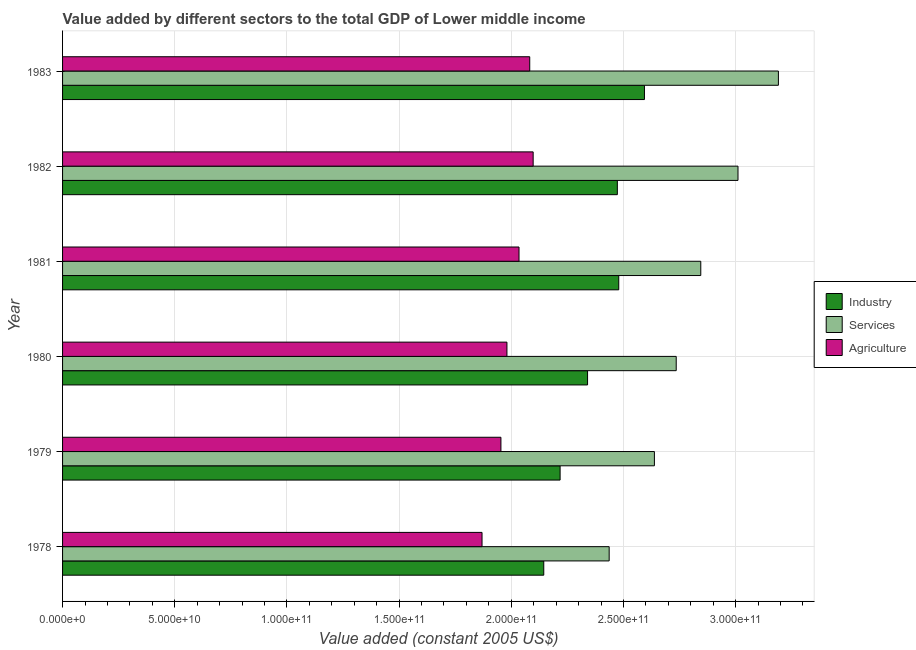How many bars are there on the 3rd tick from the top?
Ensure brevity in your answer.  3. How many bars are there on the 1st tick from the bottom?
Your response must be concise. 3. What is the label of the 4th group of bars from the top?
Ensure brevity in your answer.  1980. What is the value added by agricultural sector in 1979?
Your answer should be compact. 1.95e+11. Across all years, what is the maximum value added by industrial sector?
Provide a short and direct response. 2.59e+11. Across all years, what is the minimum value added by industrial sector?
Your answer should be very brief. 2.14e+11. In which year was the value added by industrial sector minimum?
Keep it short and to the point. 1978. What is the total value added by agricultural sector in the graph?
Provide a succinct answer. 1.20e+12. What is the difference between the value added by industrial sector in 1981 and that in 1982?
Provide a succinct answer. 6.25e+08. What is the difference between the value added by services in 1978 and the value added by industrial sector in 1982?
Ensure brevity in your answer.  -3.64e+09. What is the average value added by industrial sector per year?
Offer a very short reply. 2.37e+11. In the year 1978, what is the difference between the value added by industrial sector and value added by services?
Make the answer very short. -2.92e+1. In how many years, is the value added by services greater than 20000000000 US$?
Offer a terse response. 6. What is the ratio of the value added by industrial sector in 1978 to that in 1980?
Ensure brevity in your answer.  0.92. Is the value added by industrial sector in 1978 less than that in 1982?
Offer a terse response. Yes. Is the difference between the value added by industrial sector in 1980 and 1981 greater than the difference between the value added by agricultural sector in 1980 and 1981?
Your answer should be compact. No. What is the difference between the highest and the second highest value added by agricultural sector?
Keep it short and to the point. 1.53e+09. What is the difference between the highest and the lowest value added by industrial sector?
Provide a succinct answer. 4.49e+1. In how many years, is the value added by services greater than the average value added by services taken over all years?
Your answer should be very brief. 3. What does the 3rd bar from the top in 1980 represents?
Your answer should be compact. Industry. What does the 1st bar from the bottom in 1978 represents?
Offer a terse response. Industry. How many years are there in the graph?
Offer a terse response. 6. What is the difference between two consecutive major ticks on the X-axis?
Give a very brief answer. 5.00e+1. Are the values on the major ticks of X-axis written in scientific E-notation?
Your response must be concise. Yes. Does the graph contain any zero values?
Give a very brief answer. No. Does the graph contain grids?
Ensure brevity in your answer.  Yes. Where does the legend appear in the graph?
Offer a terse response. Center right. How are the legend labels stacked?
Make the answer very short. Vertical. What is the title of the graph?
Your answer should be very brief. Value added by different sectors to the total GDP of Lower middle income. What is the label or title of the X-axis?
Provide a succinct answer. Value added (constant 2005 US$). What is the label or title of the Y-axis?
Offer a terse response. Year. What is the Value added (constant 2005 US$) in Industry in 1978?
Give a very brief answer. 2.14e+11. What is the Value added (constant 2005 US$) in Services in 1978?
Give a very brief answer. 2.44e+11. What is the Value added (constant 2005 US$) of Agriculture in 1978?
Provide a short and direct response. 1.87e+11. What is the Value added (constant 2005 US$) of Industry in 1979?
Provide a short and direct response. 2.22e+11. What is the Value added (constant 2005 US$) of Services in 1979?
Keep it short and to the point. 2.64e+11. What is the Value added (constant 2005 US$) of Agriculture in 1979?
Your answer should be very brief. 1.95e+11. What is the Value added (constant 2005 US$) in Industry in 1980?
Give a very brief answer. 2.34e+11. What is the Value added (constant 2005 US$) in Services in 1980?
Ensure brevity in your answer.  2.74e+11. What is the Value added (constant 2005 US$) of Agriculture in 1980?
Your answer should be compact. 1.98e+11. What is the Value added (constant 2005 US$) in Industry in 1981?
Give a very brief answer. 2.48e+11. What is the Value added (constant 2005 US$) of Services in 1981?
Make the answer very short. 2.84e+11. What is the Value added (constant 2005 US$) of Agriculture in 1981?
Your answer should be compact. 2.03e+11. What is the Value added (constant 2005 US$) in Industry in 1982?
Provide a succinct answer. 2.47e+11. What is the Value added (constant 2005 US$) of Services in 1982?
Your response must be concise. 3.01e+11. What is the Value added (constant 2005 US$) in Agriculture in 1982?
Make the answer very short. 2.10e+11. What is the Value added (constant 2005 US$) in Industry in 1983?
Offer a terse response. 2.59e+11. What is the Value added (constant 2005 US$) in Services in 1983?
Your answer should be very brief. 3.19e+11. What is the Value added (constant 2005 US$) of Agriculture in 1983?
Your answer should be very brief. 2.08e+11. Across all years, what is the maximum Value added (constant 2005 US$) in Industry?
Offer a very short reply. 2.59e+11. Across all years, what is the maximum Value added (constant 2005 US$) in Services?
Provide a succinct answer. 3.19e+11. Across all years, what is the maximum Value added (constant 2005 US$) in Agriculture?
Give a very brief answer. 2.10e+11. Across all years, what is the minimum Value added (constant 2005 US$) in Industry?
Your response must be concise. 2.14e+11. Across all years, what is the minimum Value added (constant 2005 US$) of Services?
Keep it short and to the point. 2.44e+11. Across all years, what is the minimum Value added (constant 2005 US$) of Agriculture?
Offer a very short reply. 1.87e+11. What is the total Value added (constant 2005 US$) in Industry in the graph?
Give a very brief answer. 1.42e+12. What is the total Value added (constant 2005 US$) in Services in the graph?
Provide a short and direct response. 1.69e+12. What is the total Value added (constant 2005 US$) in Agriculture in the graph?
Ensure brevity in your answer.  1.20e+12. What is the difference between the Value added (constant 2005 US$) of Industry in 1978 and that in 1979?
Offer a very short reply. -7.28e+09. What is the difference between the Value added (constant 2005 US$) of Services in 1978 and that in 1979?
Provide a short and direct response. -2.02e+1. What is the difference between the Value added (constant 2005 US$) of Agriculture in 1978 and that in 1979?
Make the answer very short. -8.42e+09. What is the difference between the Value added (constant 2005 US$) of Industry in 1978 and that in 1980?
Ensure brevity in your answer.  -1.95e+1. What is the difference between the Value added (constant 2005 US$) in Services in 1978 and that in 1980?
Provide a short and direct response. -2.99e+1. What is the difference between the Value added (constant 2005 US$) of Agriculture in 1978 and that in 1980?
Offer a terse response. -1.11e+1. What is the difference between the Value added (constant 2005 US$) in Industry in 1978 and that in 1981?
Your answer should be compact. -3.34e+1. What is the difference between the Value added (constant 2005 US$) of Services in 1978 and that in 1981?
Your answer should be compact. -4.08e+1. What is the difference between the Value added (constant 2005 US$) in Agriculture in 1978 and that in 1981?
Make the answer very short. -1.65e+1. What is the difference between the Value added (constant 2005 US$) in Industry in 1978 and that in 1982?
Your answer should be compact. -3.28e+1. What is the difference between the Value added (constant 2005 US$) of Services in 1978 and that in 1982?
Ensure brevity in your answer.  -5.74e+1. What is the difference between the Value added (constant 2005 US$) of Agriculture in 1978 and that in 1982?
Your answer should be compact. -2.28e+1. What is the difference between the Value added (constant 2005 US$) of Industry in 1978 and that in 1983?
Your response must be concise. -4.49e+1. What is the difference between the Value added (constant 2005 US$) of Services in 1978 and that in 1983?
Provide a succinct answer. -7.54e+1. What is the difference between the Value added (constant 2005 US$) of Agriculture in 1978 and that in 1983?
Make the answer very short. -2.13e+1. What is the difference between the Value added (constant 2005 US$) in Industry in 1979 and that in 1980?
Offer a terse response. -1.22e+1. What is the difference between the Value added (constant 2005 US$) in Services in 1979 and that in 1980?
Give a very brief answer. -9.73e+09. What is the difference between the Value added (constant 2005 US$) of Agriculture in 1979 and that in 1980?
Make the answer very short. -2.68e+09. What is the difference between the Value added (constant 2005 US$) in Industry in 1979 and that in 1981?
Your answer should be very brief. -2.61e+1. What is the difference between the Value added (constant 2005 US$) in Services in 1979 and that in 1981?
Keep it short and to the point. -2.07e+1. What is the difference between the Value added (constant 2005 US$) of Agriculture in 1979 and that in 1981?
Offer a very short reply. -8.06e+09. What is the difference between the Value added (constant 2005 US$) of Industry in 1979 and that in 1982?
Offer a terse response. -2.55e+1. What is the difference between the Value added (constant 2005 US$) in Services in 1979 and that in 1982?
Offer a terse response. -3.73e+1. What is the difference between the Value added (constant 2005 US$) in Agriculture in 1979 and that in 1982?
Provide a short and direct response. -1.44e+1. What is the difference between the Value added (constant 2005 US$) of Industry in 1979 and that in 1983?
Give a very brief answer. -3.76e+1. What is the difference between the Value added (constant 2005 US$) in Services in 1979 and that in 1983?
Give a very brief answer. -5.53e+1. What is the difference between the Value added (constant 2005 US$) in Agriculture in 1979 and that in 1983?
Keep it short and to the point. -1.28e+1. What is the difference between the Value added (constant 2005 US$) of Industry in 1980 and that in 1981?
Make the answer very short. -1.39e+1. What is the difference between the Value added (constant 2005 US$) of Services in 1980 and that in 1981?
Your answer should be very brief. -1.09e+1. What is the difference between the Value added (constant 2005 US$) of Agriculture in 1980 and that in 1981?
Provide a succinct answer. -5.38e+09. What is the difference between the Value added (constant 2005 US$) of Industry in 1980 and that in 1982?
Make the answer very short. -1.33e+1. What is the difference between the Value added (constant 2005 US$) of Services in 1980 and that in 1982?
Keep it short and to the point. -2.75e+1. What is the difference between the Value added (constant 2005 US$) of Agriculture in 1980 and that in 1982?
Make the answer very short. -1.17e+1. What is the difference between the Value added (constant 2005 US$) in Industry in 1980 and that in 1983?
Your answer should be compact. -2.54e+1. What is the difference between the Value added (constant 2005 US$) in Services in 1980 and that in 1983?
Your answer should be very brief. -4.55e+1. What is the difference between the Value added (constant 2005 US$) in Agriculture in 1980 and that in 1983?
Your answer should be very brief. -1.02e+1. What is the difference between the Value added (constant 2005 US$) of Industry in 1981 and that in 1982?
Your answer should be compact. 6.25e+08. What is the difference between the Value added (constant 2005 US$) in Services in 1981 and that in 1982?
Ensure brevity in your answer.  -1.66e+1. What is the difference between the Value added (constant 2005 US$) in Agriculture in 1981 and that in 1982?
Keep it short and to the point. -6.31e+09. What is the difference between the Value added (constant 2005 US$) of Industry in 1981 and that in 1983?
Provide a short and direct response. -1.15e+1. What is the difference between the Value added (constant 2005 US$) in Services in 1981 and that in 1983?
Give a very brief answer. -3.46e+1. What is the difference between the Value added (constant 2005 US$) of Agriculture in 1981 and that in 1983?
Offer a very short reply. -4.77e+09. What is the difference between the Value added (constant 2005 US$) of Industry in 1982 and that in 1983?
Your answer should be very brief. -1.21e+1. What is the difference between the Value added (constant 2005 US$) in Services in 1982 and that in 1983?
Your answer should be compact. -1.80e+1. What is the difference between the Value added (constant 2005 US$) in Agriculture in 1982 and that in 1983?
Give a very brief answer. 1.53e+09. What is the difference between the Value added (constant 2005 US$) in Industry in 1978 and the Value added (constant 2005 US$) in Services in 1979?
Offer a terse response. -4.93e+1. What is the difference between the Value added (constant 2005 US$) in Industry in 1978 and the Value added (constant 2005 US$) in Agriculture in 1979?
Offer a terse response. 1.91e+1. What is the difference between the Value added (constant 2005 US$) of Services in 1978 and the Value added (constant 2005 US$) of Agriculture in 1979?
Your answer should be very brief. 4.82e+1. What is the difference between the Value added (constant 2005 US$) of Industry in 1978 and the Value added (constant 2005 US$) of Services in 1980?
Make the answer very short. -5.90e+1. What is the difference between the Value added (constant 2005 US$) of Industry in 1978 and the Value added (constant 2005 US$) of Agriculture in 1980?
Make the answer very short. 1.64e+1. What is the difference between the Value added (constant 2005 US$) in Services in 1978 and the Value added (constant 2005 US$) in Agriculture in 1980?
Your answer should be very brief. 4.56e+1. What is the difference between the Value added (constant 2005 US$) of Industry in 1978 and the Value added (constant 2005 US$) of Services in 1981?
Give a very brief answer. -7.00e+1. What is the difference between the Value added (constant 2005 US$) in Industry in 1978 and the Value added (constant 2005 US$) in Agriculture in 1981?
Offer a terse response. 1.10e+1. What is the difference between the Value added (constant 2005 US$) in Services in 1978 and the Value added (constant 2005 US$) in Agriculture in 1981?
Make the answer very short. 4.02e+1. What is the difference between the Value added (constant 2005 US$) of Industry in 1978 and the Value added (constant 2005 US$) of Services in 1982?
Your answer should be very brief. -8.66e+1. What is the difference between the Value added (constant 2005 US$) in Industry in 1978 and the Value added (constant 2005 US$) in Agriculture in 1982?
Make the answer very short. 4.73e+09. What is the difference between the Value added (constant 2005 US$) of Services in 1978 and the Value added (constant 2005 US$) of Agriculture in 1982?
Provide a succinct answer. 3.39e+1. What is the difference between the Value added (constant 2005 US$) of Industry in 1978 and the Value added (constant 2005 US$) of Services in 1983?
Give a very brief answer. -1.05e+11. What is the difference between the Value added (constant 2005 US$) in Industry in 1978 and the Value added (constant 2005 US$) in Agriculture in 1983?
Ensure brevity in your answer.  6.26e+09. What is the difference between the Value added (constant 2005 US$) of Services in 1978 and the Value added (constant 2005 US$) of Agriculture in 1983?
Your response must be concise. 3.54e+1. What is the difference between the Value added (constant 2005 US$) of Industry in 1979 and the Value added (constant 2005 US$) of Services in 1980?
Offer a very short reply. -5.18e+1. What is the difference between the Value added (constant 2005 US$) in Industry in 1979 and the Value added (constant 2005 US$) in Agriculture in 1980?
Provide a short and direct response. 2.37e+1. What is the difference between the Value added (constant 2005 US$) of Services in 1979 and the Value added (constant 2005 US$) of Agriculture in 1980?
Your response must be concise. 6.57e+1. What is the difference between the Value added (constant 2005 US$) of Industry in 1979 and the Value added (constant 2005 US$) of Services in 1981?
Your answer should be compact. -6.27e+1. What is the difference between the Value added (constant 2005 US$) in Industry in 1979 and the Value added (constant 2005 US$) in Agriculture in 1981?
Your answer should be compact. 1.83e+1. What is the difference between the Value added (constant 2005 US$) in Services in 1979 and the Value added (constant 2005 US$) in Agriculture in 1981?
Provide a succinct answer. 6.03e+1. What is the difference between the Value added (constant 2005 US$) in Industry in 1979 and the Value added (constant 2005 US$) in Services in 1982?
Provide a short and direct response. -7.93e+1. What is the difference between the Value added (constant 2005 US$) of Industry in 1979 and the Value added (constant 2005 US$) of Agriculture in 1982?
Offer a terse response. 1.20e+1. What is the difference between the Value added (constant 2005 US$) of Services in 1979 and the Value added (constant 2005 US$) of Agriculture in 1982?
Make the answer very short. 5.40e+1. What is the difference between the Value added (constant 2005 US$) of Industry in 1979 and the Value added (constant 2005 US$) of Services in 1983?
Your answer should be very brief. -9.73e+1. What is the difference between the Value added (constant 2005 US$) in Industry in 1979 and the Value added (constant 2005 US$) in Agriculture in 1983?
Offer a terse response. 1.35e+1. What is the difference between the Value added (constant 2005 US$) in Services in 1979 and the Value added (constant 2005 US$) in Agriculture in 1983?
Provide a short and direct response. 5.56e+1. What is the difference between the Value added (constant 2005 US$) in Industry in 1980 and the Value added (constant 2005 US$) in Services in 1981?
Offer a very short reply. -5.05e+1. What is the difference between the Value added (constant 2005 US$) of Industry in 1980 and the Value added (constant 2005 US$) of Agriculture in 1981?
Your answer should be very brief. 3.06e+1. What is the difference between the Value added (constant 2005 US$) of Services in 1980 and the Value added (constant 2005 US$) of Agriculture in 1981?
Your answer should be very brief. 7.01e+1. What is the difference between the Value added (constant 2005 US$) of Industry in 1980 and the Value added (constant 2005 US$) of Services in 1982?
Provide a succinct answer. -6.71e+1. What is the difference between the Value added (constant 2005 US$) in Industry in 1980 and the Value added (constant 2005 US$) in Agriculture in 1982?
Provide a short and direct response. 2.42e+1. What is the difference between the Value added (constant 2005 US$) in Services in 1980 and the Value added (constant 2005 US$) in Agriculture in 1982?
Provide a succinct answer. 6.38e+1. What is the difference between the Value added (constant 2005 US$) of Industry in 1980 and the Value added (constant 2005 US$) of Services in 1983?
Provide a succinct answer. -8.51e+1. What is the difference between the Value added (constant 2005 US$) of Industry in 1980 and the Value added (constant 2005 US$) of Agriculture in 1983?
Ensure brevity in your answer.  2.58e+1. What is the difference between the Value added (constant 2005 US$) in Services in 1980 and the Value added (constant 2005 US$) in Agriculture in 1983?
Ensure brevity in your answer.  6.53e+1. What is the difference between the Value added (constant 2005 US$) in Industry in 1981 and the Value added (constant 2005 US$) in Services in 1982?
Your response must be concise. -5.32e+1. What is the difference between the Value added (constant 2005 US$) of Industry in 1981 and the Value added (constant 2005 US$) of Agriculture in 1982?
Keep it short and to the point. 3.81e+1. What is the difference between the Value added (constant 2005 US$) of Services in 1981 and the Value added (constant 2005 US$) of Agriculture in 1982?
Your answer should be compact. 7.47e+1. What is the difference between the Value added (constant 2005 US$) in Industry in 1981 and the Value added (constant 2005 US$) in Services in 1983?
Ensure brevity in your answer.  -7.12e+1. What is the difference between the Value added (constant 2005 US$) of Industry in 1981 and the Value added (constant 2005 US$) of Agriculture in 1983?
Offer a terse response. 3.97e+1. What is the difference between the Value added (constant 2005 US$) in Services in 1981 and the Value added (constant 2005 US$) in Agriculture in 1983?
Make the answer very short. 7.62e+1. What is the difference between the Value added (constant 2005 US$) in Industry in 1982 and the Value added (constant 2005 US$) in Services in 1983?
Offer a very short reply. -7.18e+1. What is the difference between the Value added (constant 2005 US$) in Industry in 1982 and the Value added (constant 2005 US$) in Agriculture in 1983?
Keep it short and to the point. 3.91e+1. What is the difference between the Value added (constant 2005 US$) of Services in 1982 and the Value added (constant 2005 US$) of Agriculture in 1983?
Provide a short and direct response. 9.28e+1. What is the average Value added (constant 2005 US$) in Industry per year?
Your answer should be very brief. 2.37e+11. What is the average Value added (constant 2005 US$) of Services per year?
Give a very brief answer. 2.81e+11. What is the average Value added (constant 2005 US$) of Agriculture per year?
Make the answer very short. 2.00e+11. In the year 1978, what is the difference between the Value added (constant 2005 US$) of Industry and Value added (constant 2005 US$) of Services?
Offer a terse response. -2.92e+1. In the year 1978, what is the difference between the Value added (constant 2005 US$) of Industry and Value added (constant 2005 US$) of Agriculture?
Provide a succinct answer. 2.75e+1. In the year 1978, what is the difference between the Value added (constant 2005 US$) of Services and Value added (constant 2005 US$) of Agriculture?
Provide a succinct answer. 5.67e+1. In the year 1979, what is the difference between the Value added (constant 2005 US$) in Industry and Value added (constant 2005 US$) in Services?
Your response must be concise. -4.20e+1. In the year 1979, what is the difference between the Value added (constant 2005 US$) of Industry and Value added (constant 2005 US$) of Agriculture?
Your response must be concise. 2.64e+1. In the year 1979, what is the difference between the Value added (constant 2005 US$) in Services and Value added (constant 2005 US$) in Agriculture?
Provide a succinct answer. 6.84e+1. In the year 1980, what is the difference between the Value added (constant 2005 US$) in Industry and Value added (constant 2005 US$) in Services?
Give a very brief answer. -3.95e+1. In the year 1980, what is the difference between the Value added (constant 2005 US$) of Industry and Value added (constant 2005 US$) of Agriculture?
Give a very brief answer. 3.59e+1. In the year 1980, what is the difference between the Value added (constant 2005 US$) in Services and Value added (constant 2005 US$) in Agriculture?
Your answer should be compact. 7.55e+1. In the year 1981, what is the difference between the Value added (constant 2005 US$) of Industry and Value added (constant 2005 US$) of Services?
Ensure brevity in your answer.  -3.66e+1. In the year 1981, what is the difference between the Value added (constant 2005 US$) of Industry and Value added (constant 2005 US$) of Agriculture?
Your response must be concise. 4.45e+1. In the year 1981, what is the difference between the Value added (constant 2005 US$) in Services and Value added (constant 2005 US$) in Agriculture?
Keep it short and to the point. 8.10e+1. In the year 1982, what is the difference between the Value added (constant 2005 US$) in Industry and Value added (constant 2005 US$) in Services?
Make the answer very short. -5.38e+1. In the year 1982, what is the difference between the Value added (constant 2005 US$) in Industry and Value added (constant 2005 US$) in Agriculture?
Provide a succinct answer. 3.75e+1. In the year 1982, what is the difference between the Value added (constant 2005 US$) of Services and Value added (constant 2005 US$) of Agriculture?
Provide a succinct answer. 9.13e+1. In the year 1983, what is the difference between the Value added (constant 2005 US$) of Industry and Value added (constant 2005 US$) of Services?
Offer a terse response. -5.97e+1. In the year 1983, what is the difference between the Value added (constant 2005 US$) in Industry and Value added (constant 2005 US$) in Agriculture?
Make the answer very short. 5.11e+1. In the year 1983, what is the difference between the Value added (constant 2005 US$) in Services and Value added (constant 2005 US$) in Agriculture?
Give a very brief answer. 1.11e+11. What is the ratio of the Value added (constant 2005 US$) of Industry in 1978 to that in 1979?
Your answer should be very brief. 0.97. What is the ratio of the Value added (constant 2005 US$) of Services in 1978 to that in 1979?
Ensure brevity in your answer.  0.92. What is the ratio of the Value added (constant 2005 US$) in Agriculture in 1978 to that in 1979?
Your answer should be compact. 0.96. What is the ratio of the Value added (constant 2005 US$) of Industry in 1978 to that in 1980?
Your answer should be compact. 0.92. What is the ratio of the Value added (constant 2005 US$) of Services in 1978 to that in 1980?
Offer a terse response. 0.89. What is the ratio of the Value added (constant 2005 US$) of Agriculture in 1978 to that in 1980?
Your answer should be compact. 0.94. What is the ratio of the Value added (constant 2005 US$) of Industry in 1978 to that in 1981?
Offer a terse response. 0.87. What is the ratio of the Value added (constant 2005 US$) in Services in 1978 to that in 1981?
Give a very brief answer. 0.86. What is the ratio of the Value added (constant 2005 US$) in Agriculture in 1978 to that in 1981?
Your answer should be very brief. 0.92. What is the ratio of the Value added (constant 2005 US$) of Industry in 1978 to that in 1982?
Ensure brevity in your answer.  0.87. What is the ratio of the Value added (constant 2005 US$) in Services in 1978 to that in 1982?
Provide a short and direct response. 0.81. What is the ratio of the Value added (constant 2005 US$) of Agriculture in 1978 to that in 1982?
Give a very brief answer. 0.89. What is the ratio of the Value added (constant 2005 US$) of Industry in 1978 to that in 1983?
Provide a short and direct response. 0.83. What is the ratio of the Value added (constant 2005 US$) in Services in 1978 to that in 1983?
Offer a very short reply. 0.76. What is the ratio of the Value added (constant 2005 US$) in Agriculture in 1978 to that in 1983?
Offer a very short reply. 0.9. What is the ratio of the Value added (constant 2005 US$) in Industry in 1979 to that in 1980?
Ensure brevity in your answer.  0.95. What is the ratio of the Value added (constant 2005 US$) of Services in 1979 to that in 1980?
Keep it short and to the point. 0.96. What is the ratio of the Value added (constant 2005 US$) of Agriculture in 1979 to that in 1980?
Your response must be concise. 0.99. What is the ratio of the Value added (constant 2005 US$) in Industry in 1979 to that in 1981?
Your response must be concise. 0.89. What is the ratio of the Value added (constant 2005 US$) in Services in 1979 to that in 1981?
Your response must be concise. 0.93. What is the ratio of the Value added (constant 2005 US$) of Agriculture in 1979 to that in 1981?
Your response must be concise. 0.96. What is the ratio of the Value added (constant 2005 US$) in Industry in 1979 to that in 1982?
Offer a terse response. 0.9. What is the ratio of the Value added (constant 2005 US$) of Services in 1979 to that in 1982?
Offer a very short reply. 0.88. What is the ratio of the Value added (constant 2005 US$) in Agriculture in 1979 to that in 1982?
Keep it short and to the point. 0.93. What is the ratio of the Value added (constant 2005 US$) of Industry in 1979 to that in 1983?
Your response must be concise. 0.85. What is the ratio of the Value added (constant 2005 US$) in Services in 1979 to that in 1983?
Make the answer very short. 0.83. What is the ratio of the Value added (constant 2005 US$) of Agriculture in 1979 to that in 1983?
Provide a succinct answer. 0.94. What is the ratio of the Value added (constant 2005 US$) of Industry in 1980 to that in 1981?
Your answer should be compact. 0.94. What is the ratio of the Value added (constant 2005 US$) in Services in 1980 to that in 1981?
Provide a short and direct response. 0.96. What is the ratio of the Value added (constant 2005 US$) in Agriculture in 1980 to that in 1981?
Make the answer very short. 0.97. What is the ratio of the Value added (constant 2005 US$) in Industry in 1980 to that in 1982?
Offer a terse response. 0.95. What is the ratio of the Value added (constant 2005 US$) in Services in 1980 to that in 1982?
Your response must be concise. 0.91. What is the ratio of the Value added (constant 2005 US$) in Agriculture in 1980 to that in 1982?
Offer a very short reply. 0.94. What is the ratio of the Value added (constant 2005 US$) in Industry in 1980 to that in 1983?
Offer a very short reply. 0.9. What is the ratio of the Value added (constant 2005 US$) of Services in 1980 to that in 1983?
Ensure brevity in your answer.  0.86. What is the ratio of the Value added (constant 2005 US$) in Agriculture in 1980 to that in 1983?
Your answer should be compact. 0.95. What is the ratio of the Value added (constant 2005 US$) in Industry in 1981 to that in 1982?
Provide a succinct answer. 1. What is the ratio of the Value added (constant 2005 US$) of Services in 1981 to that in 1982?
Provide a short and direct response. 0.94. What is the ratio of the Value added (constant 2005 US$) of Agriculture in 1981 to that in 1982?
Make the answer very short. 0.97. What is the ratio of the Value added (constant 2005 US$) of Industry in 1981 to that in 1983?
Provide a succinct answer. 0.96. What is the ratio of the Value added (constant 2005 US$) of Services in 1981 to that in 1983?
Provide a succinct answer. 0.89. What is the ratio of the Value added (constant 2005 US$) of Agriculture in 1981 to that in 1983?
Your answer should be very brief. 0.98. What is the ratio of the Value added (constant 2005 US$) in Industry in 1982 to that in 1983?
Ensure brevity in your answer.  0.95. What is the ratio of the Value added (constant 2005 US$) of Services in 1982 to that in 1983?
Ensure brevity in your answer.  0.94. What is the ratio of the Value added (constant 2005 US$) in Agriculture in 1982 to that in 1983?
Make the answer very short. 1.01. What is the difference between the highest and the second highest Value added (constant 2005 US$) in Industry?
Give a very brief answer. 1.15e+1. What is the difference between the highest and the second highest Value added (constant 2005 US$) in Services?
Provide a succinct answer. 1.80e+1. What is the difference between the highest and the second highest Value added (constant 2005 US$) in Agriculture?
Offer a terse response. 1.53e+09. What is the difference between the highest and the lowest Value added (constant 2005 US$) in Industry?
Give a very brief answer. 4.49e+1. What is the difference between the highest and the lowest Value added (constant 2005 US$) in Services?
Provide a short and direct response. 7.54e+1. What is the difference between the highest and the lowest Value added (constant 2005 US$) of Agriculture?
Offer a very short reply. 2.28e+1. 